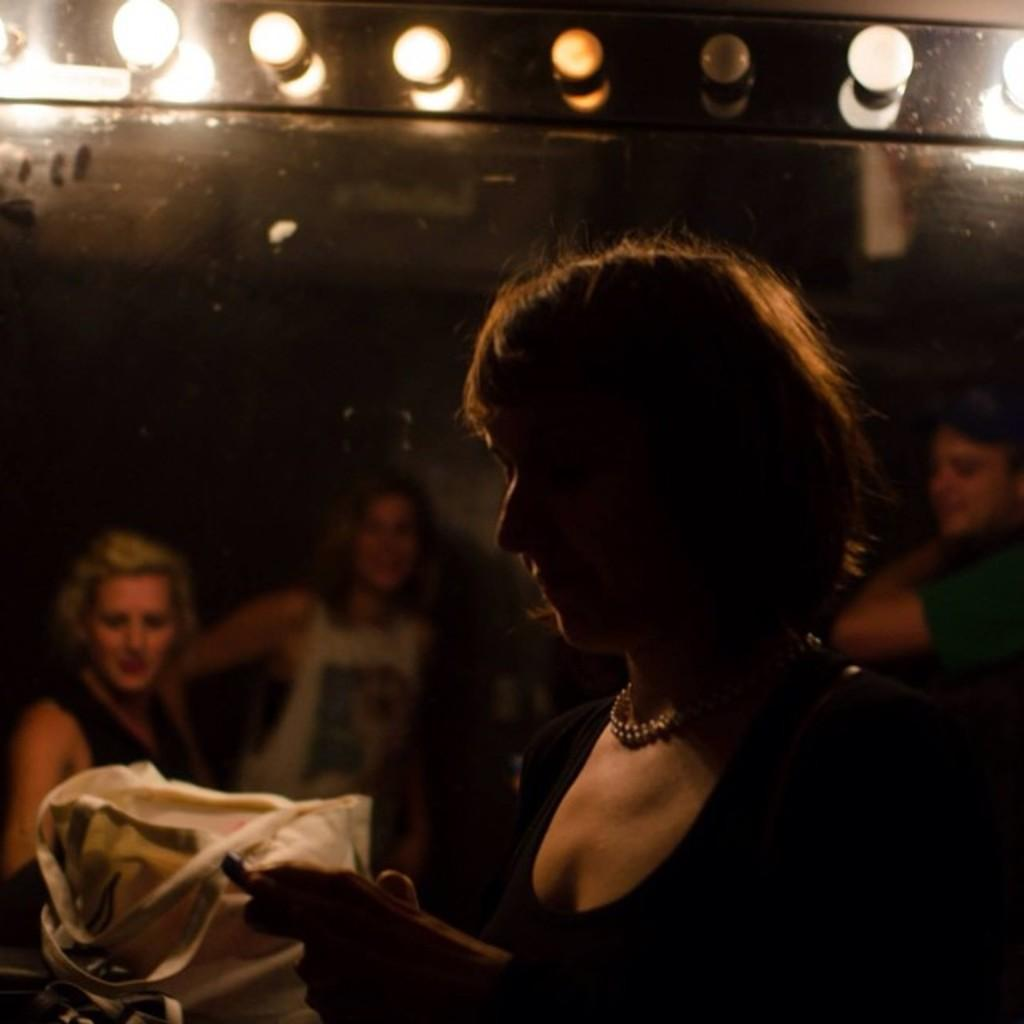Who is the main subject in the image? There is a woman in the image. What can be seen in the background of the image? There is a group of people and some objects visible in the background of the image. What is the source of illumination in the image? There are lights visible in the image. What type of insurance policy is the woman discussing with the group in the image? There is no indication in the image that the woman is discussing insurance with the group. --- Facts: 1. There is a car in the image. 2. The car is parked on the street. 3. There are trees on both sides of the street. 4. The sky is visible in the image. Absurd Topics: parrot, ocean, dance Conversation: What is the main subject in the image? There is a car in the image. Where is the car located? The car is parked on the street. What can be seen on both sides of the street? There are trees on both sides of the street. What is visible in the image besides the car and trees? The sky is visible in the image. Reasoning: Let's think step by step in order to produce the conversation. We start by identifying the main subject in the image, which is the car. Then, we describe the car's location, which is parked on the street. Next, we mention the trees on both sides of the street, which provide context for the setting. Finally, we acknowledge the presence of the sky, which is visible in the image. Absurd Question/Answer: Can you tell me how many parrots are sitting on the car in the image? There are no parrots present in the image; it features a car parked on the street with trees on both sides and the sky visible. --- Facts: 1. There is a person sitting on a bench in the image. 2. The person is reading a book. 3. There is a tree behind the bench. 4. The ground is visible in the image. Absurd Topics: fireworks, chess, elephant Conversation: Who is the main subject in the image? There is a person sitting on a bench in the image. What is the person doing while sitting on the bench? The person is reading a book. What can be seen behind the bench? There is a tree behind the bench. What is visible on the ground in the image? The ground is visible in the image. Reasoning: Let's think step by step in order to produce the conversation. We start by identifying the main subject in the image, which is the person sitting on the bench. Then, we describe the person's activity, which is reading a book. Next, we mention the tree behind the bench, which provides context for the setting. Finally, we acknowledge the presence of the ground, which is visible in the image 